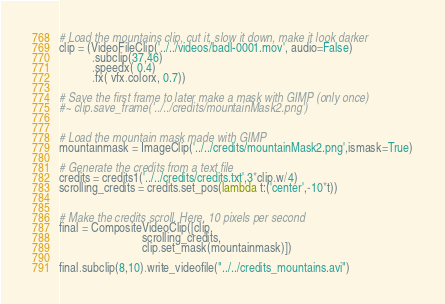Convert code to text. <code><loc_0><loc_0><loc_500><loc_500><_Python_># Load the mountains clip, cut it, slow it down, make it look darker
clip = (VideoFileClip('../../videos/badl-0001.mov', audio=False)
           .subclip(37,46)
           .speedx( 0.4)
           .fx( vfx.colorx, 0.7))

# Save the first frame to later make a mask with GIMP (only once)
#~ clip.save_frame('../../credits/mountainMask2.png')


# Load the mountain mask made with GIMP
mountainmask = ImageClip('../../credits/mountainMask2.png',ismask=True)

# Generate the credits from a text file
credits = credits1('../../credits/credits.txt',3*clip.w/4)
scrolling_credits = credits.set_pos(lambda t:('center',-10*t))


# Make the credits scroll. Here, 10 pixels per second
final = CompositeVideoClip([clip,
                            scrolling_credits,
                            clip.set_mask(mountainmask)])
                            
final.subclip(8,10).write_videofile("../../credits_mountains.avi")
</code> 